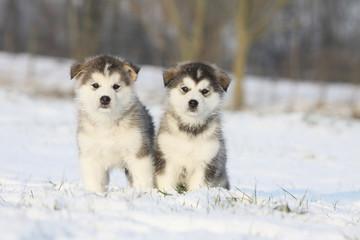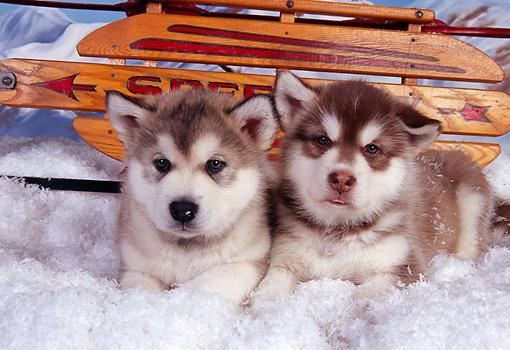The first image is the image on the left, the second image is the image on the right. Considering the images on both sides, is "The combined images show four puppies of the same breed in the snow." valid? Answer yes or no. Yes. The first image is the image on the left, the second image is the image on the right. For the images displayed, is the sentence "At least one photo shows a single dog facing forward, standing on grass." factually correct? Answer yes or no. No. 